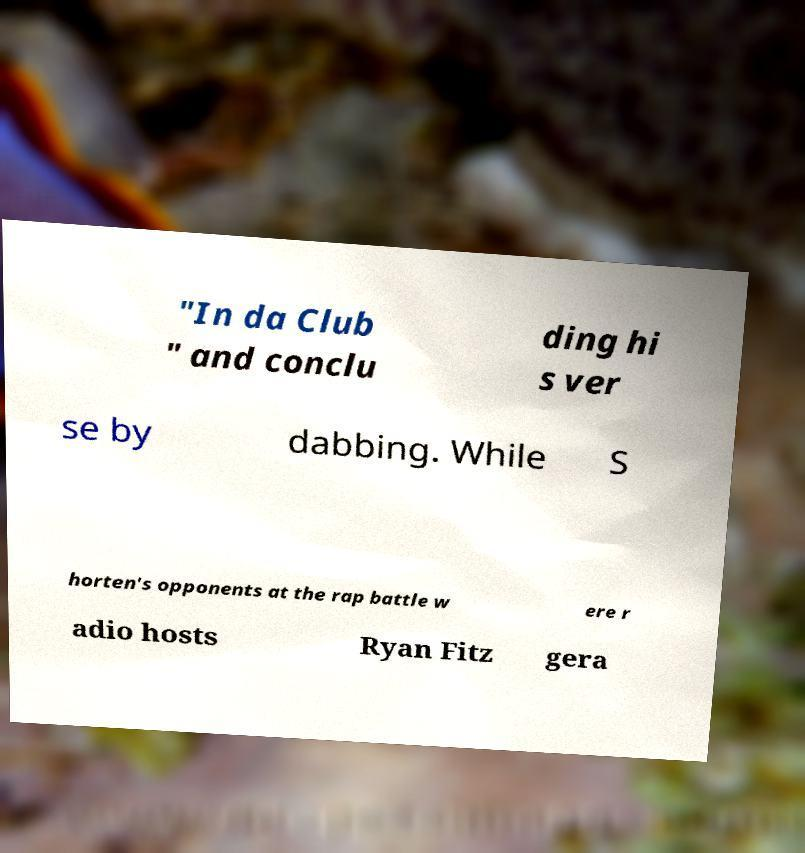Could you extract and type out the text from this image? "In da Club " and conclu ding hi s ver se by dabbing. While S horten's opponents at the rap battle w ere r adio hosts Ryan Fitz gera 